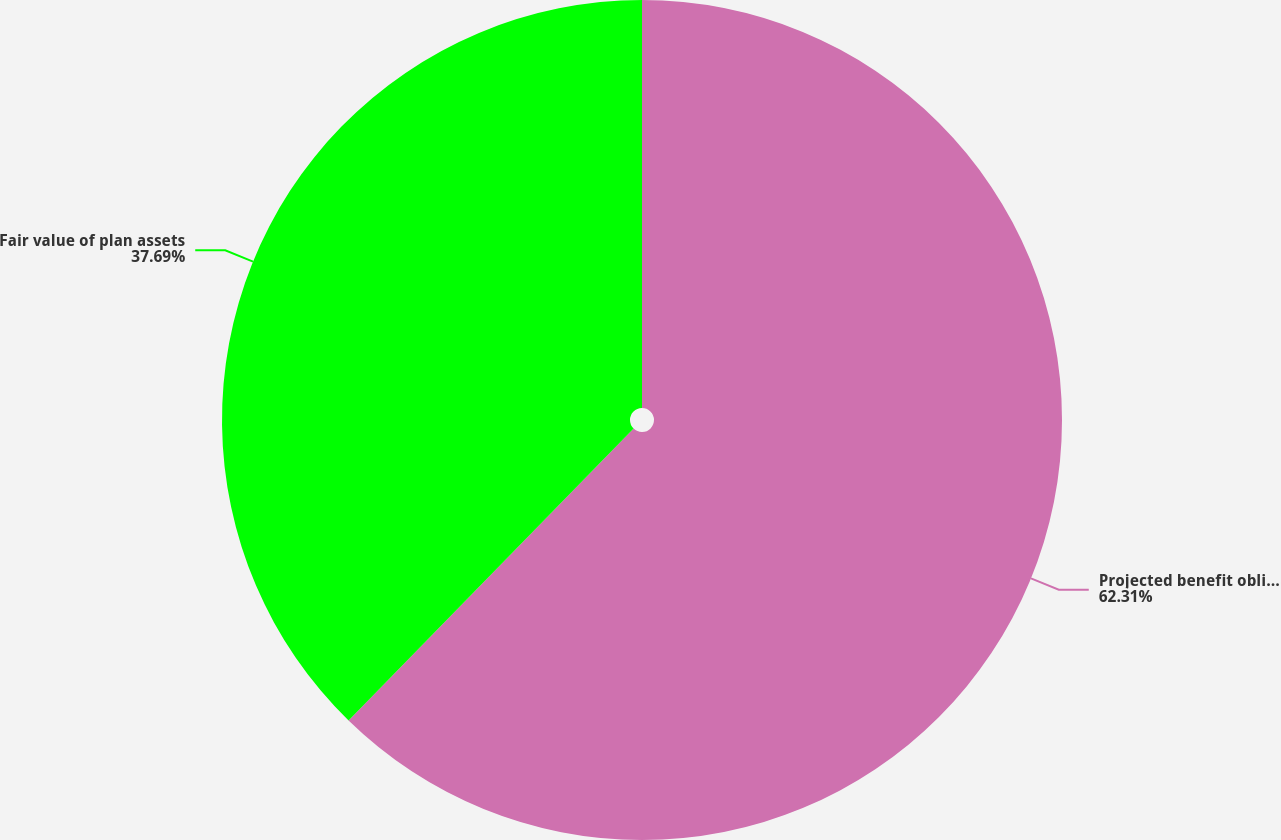<chart> <loc_0><loc_0><loc_500><loc_500><pie_chart><fcel>Projected benefit obligation<fcel>Fair value of plan assets<nl><fcel>62.31%<fcel>37.69%<nl></chart> 